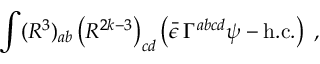<formula> <loc_0><loc_0><loc_500><loc_500>\int ( R ^ { 3 } ) _ { a b } \left ( R ^ { 2 k - 3 } \right ) _ { c d } \left ( \bar { \epsilon } \, \Gamma ^ { a b c d } \psi - h . c . \right ) \, ,</formula> 